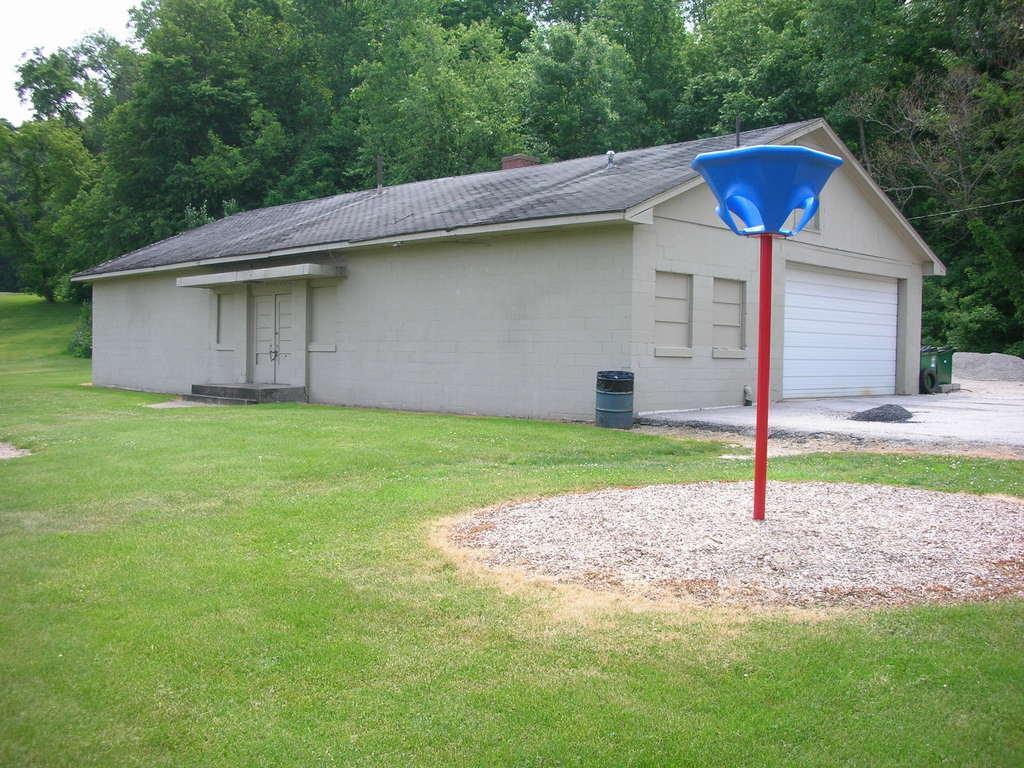In one or two sentences, can you explain what this image depicts? In the front of the image there is a house, pole, grass and objects. In the background of the image there are trees and sky. Land is covered with grass.   